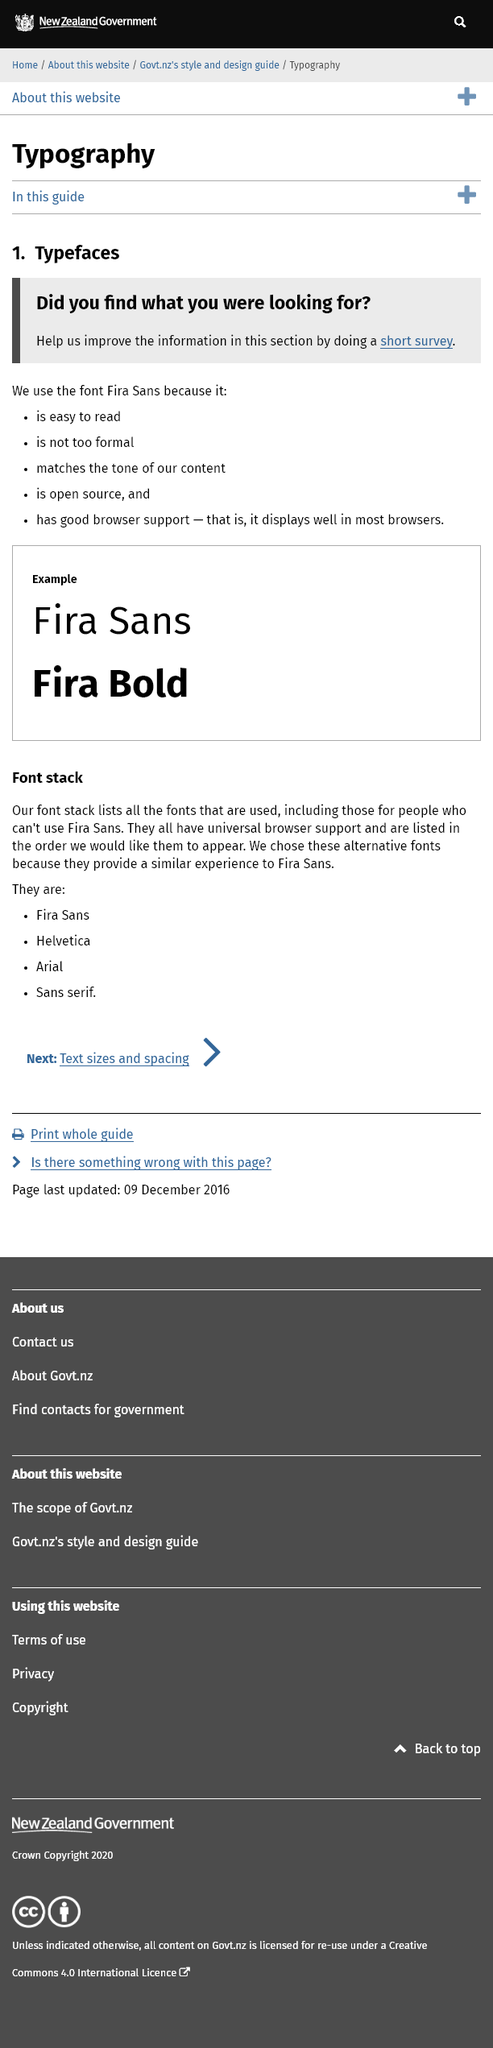Point out several critical features in this image. The two fonts discussed on this page are Fira Sans and Fira Bold. Fira Sans has an open source license that allows for free use and modification of the font. The Fira Sans font has excellent browser support and is displayed well in most popular browsers. 